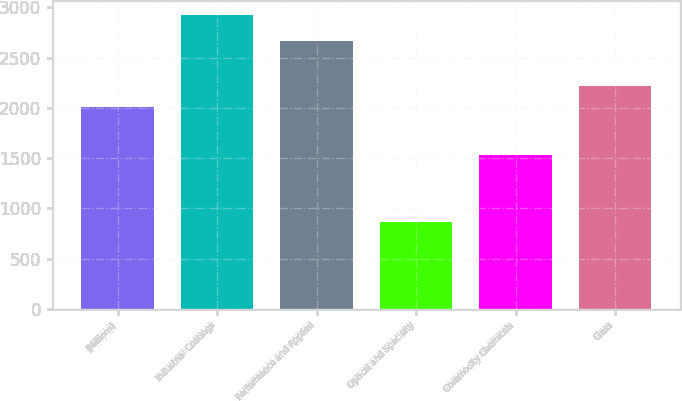Convert chart to OTSL. <chart><loc_0><loc_0><loc_500><loc_500><bar_chart><fcel>(Millions)<fcel>Industrial Coatings<fcel>Performance and Applied<fcel>Optical and Specialty<fcel>Commodity Chemicals<fcel>Glass<nl><fcel>2005<fcel>2921<fcel>2668<fcel>867<fcel>1531<fcel>2214<nl></chart> 